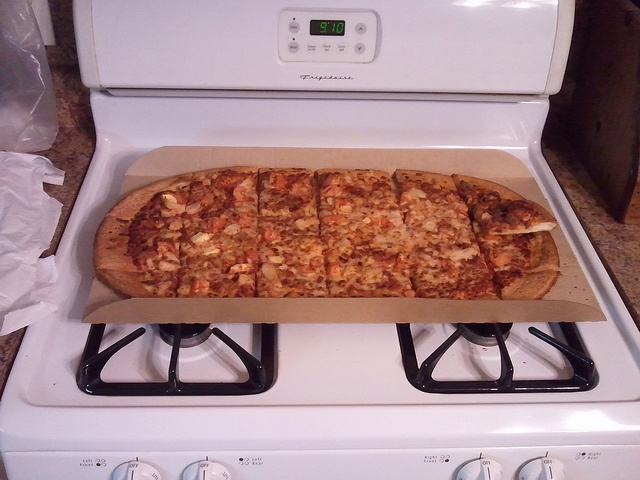Describe the objects in this image and their specific colors. I can see oven in lavender, lightgray, gray, brown, and darkgray tones, pizza in gray, brown, red, and salmon tones, pizza in gray, brown, and maroon tones, and pizza in gray, brown, maroon, and red tones in this image. 